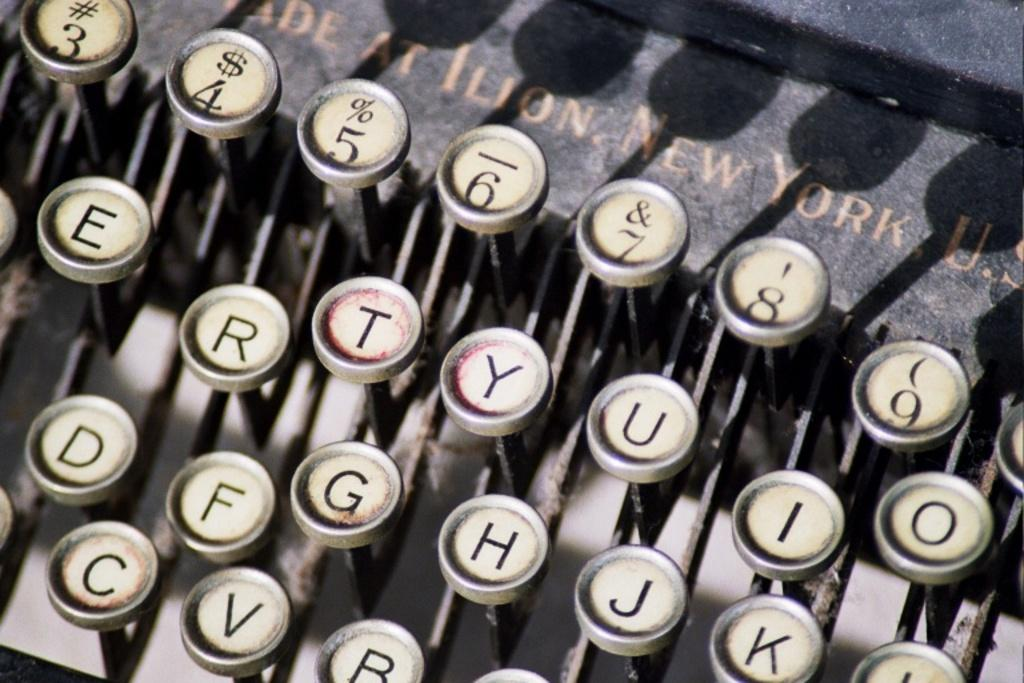Provide a one-sentence caption for the provided image. A vintage made in New York U.S. typewriter. 